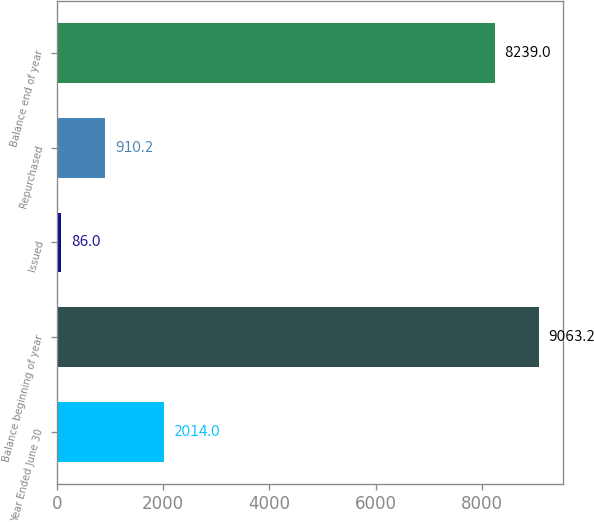Convert chart to OTSL. <chart><loc_0><loc_0><loc_500><loc_500><bar_chart><fcel>Year Ended June 30<fcel>Balance beginning of year<fcel>Issued<fcel>Repurchased<fcel>Balance end of year<nl><fcel>2014<fcel>9063.2<fcel>86<fcel>910.2<fcel>8239<nl></chart> 